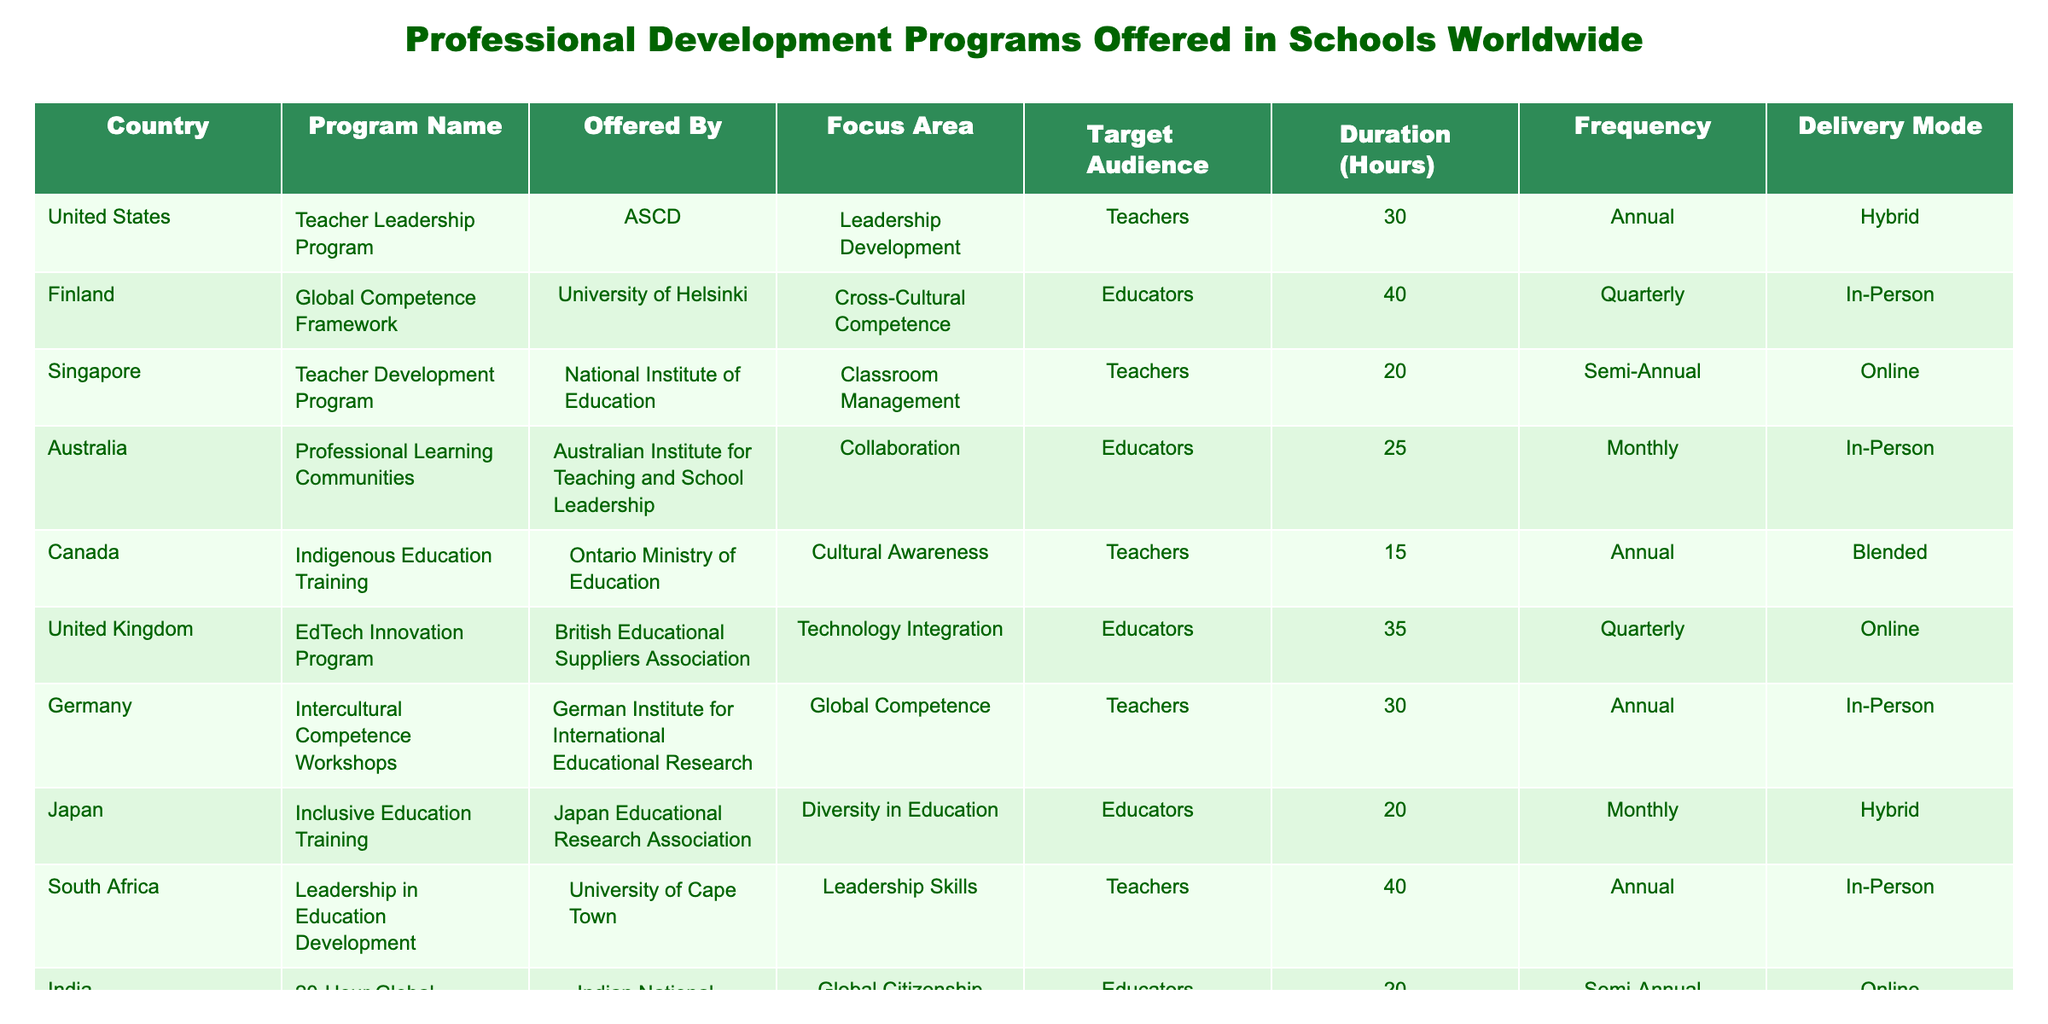What is the duration of the Teacher Leadership Program offered in the United States? The table shows that the duration of the Teacher Leadership Program in the United States is 30 hours. This information can be found in the "Duration (Hours)" column corresponding to the "Teacher Leadership Program" row.
Answer: 30 hours Which program has the shortest duration and what is that duration? By examining the "Duration (Hours)" column, we can see the durations are 30, 40, 20, 25, 15, 35, 30, 20, 40, and 20 hours respectively. The shortest duration is 15 hours, which belongs to the Indigenous Education Training program offered in Canada.
Answer: 15 hours Is the EdTech Innovation Program aimed solely at teachers? The EdTech Innovation Program is listed as a program for "Educators" in the table, which suggests it is not limited to teachers alone but may include other education professionals as well. Therefore, the answer is no.
Answer: No What are the frequency types of the programs offered in Australia and Japan? The frequency for Australia is "Monthly" and for Japan is also "Monthly." This can be found by checking the "Frequency" column for their respective programs.
Answer: Monthly for both How many hours of professional development do educators receive on average across the listed programs? The durations of the listed programs are 30, 40, 20, 25, 15, 35, 30, 20, 40, and 20 hours. First, we add these values to get a total of 30 + 40 + 20 + 25 + 15 + 35 + 30 + 20 + 40 + 20 =  350 hours. Then, we divide this total by the number of programs, which is 10, resulting in an average of 350 / 10 = 35 hours.
Answer: 35 hours Which country offers a program focusing on Cultural Awareness and what is its delivery mode? The program focusing on Cultural Awareness is the Indigenous Education Training offered by the Ontario Ministry of Education in Canada. The delivery mode is noted as "Blended" in the table.
Answer: Canada, Blended How do the focus areas vary among the programs from Germany and South Africa? Germany's program focuses on "Global Competence" while South Africa's focuses on "Leadership Skills." This information can be compared by looking at the "Focus Area" column for their respective programs.
Answer: Global Competence and Leadership Skills Are there more programs delivered online or in-person? There are four programs delivered online (Singapore, United Kingdom, India) and five programs delivered in-person (Finland, Australia, Germany, South Africa, Japan). This can be determined by counting the delivery modes in the "Delivery Mode" column.
Answer: More in-person programs Which program has a focus area in Global Citizenship and how many hours does it entail? The program with a focus area in Global Citizenship is the 20-Hour Global Learning Course offered in India, which involves a duration of 20 hours. This can be found by checking the "Focus Area" and "Duration (Hours)" columns for the corresponding program.
Answer: 20 hours 